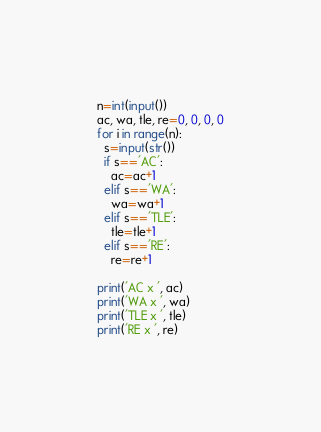Convert code to text. <code><loc_0><loc_0><loc_500><loc_500><_Python_>n=int(input())
ac, wa, tle, re=0, 0, 0, 0
for i in range(n):
  s=input(str())
  if s=='AC':
    ac=ac+1
  elif s=='WA':
    wa=wa+1
  elif s=='TLE':
    tle=tle+1
  elif s=='RE':
    re=re+1

print('AC x ', ac)
print('WA x ', wa)
print('TLE x ', tle)
print('RE x ', re)</code> 